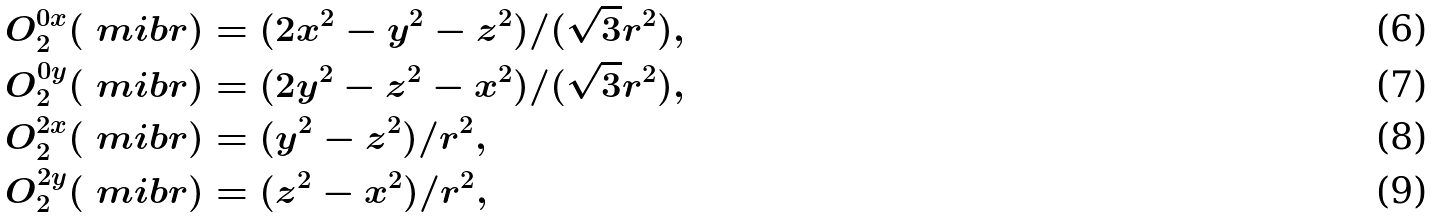<formula> <loc_0><loc_0><loc_500><loc_500>O ^ { 0 x } _ { 2 } ( \ m i b { r } ) & = ( 2 x ^ { 2 } - y ^ { 2 } - z ^ { 2 } ) / ( \sqrt { 3 } r ^ { 2 } ) , \\ O ^ { 0 y } _ { 2 } ( \ m i b { r } ) & = ( 2 y ^ { 2 } - z ^ { 2 } - x ^ { 2 } ) / ( \sqrt { 3 } r ^ { 2 } ) , \\ O ^ { 2 x } _ { 2 } ( \ m i b { r } ) & = ( y ^ { 2 } - z ^ { 2 } ) / r ^ { 2 } , \\ O ^ { 2 y } _ { 2 } ( \ m i b { r } ) & = ( z ^ { 2 } - x ^ { 2 } ) / r ^ { 2 } ,</formula> 